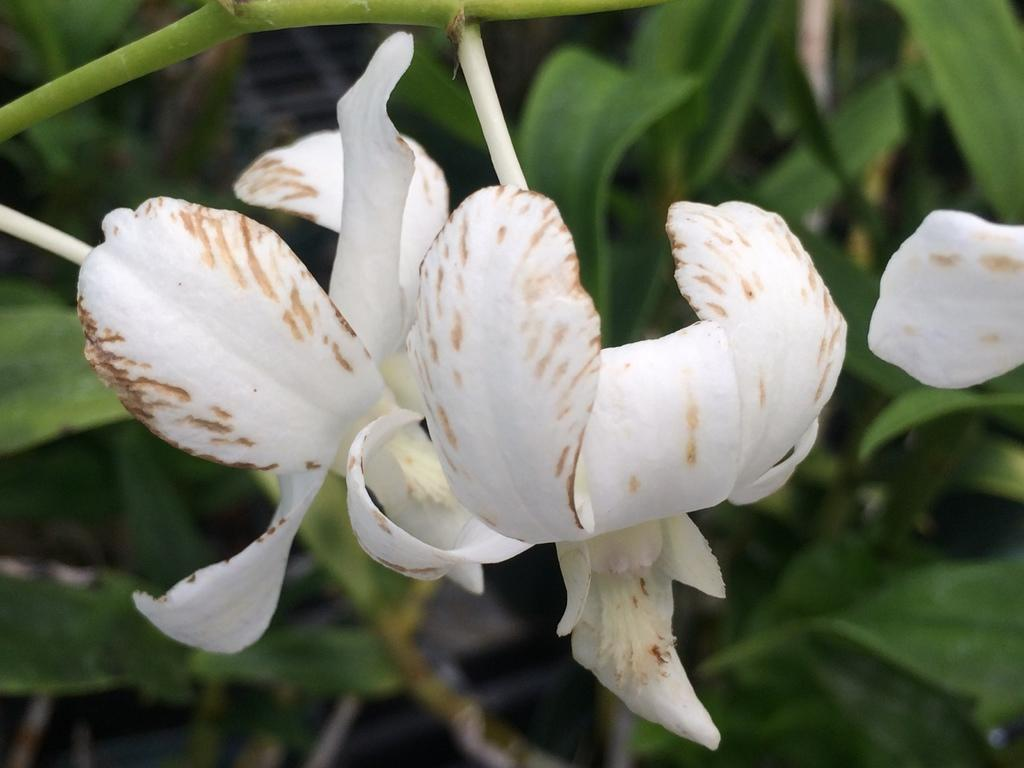What type of flora can be seen in the image? There are flowers in the image. What color are the flowers? The flowers are white in color. What else can be seen in the image besides the flowers? There are stems visible in the image. What type of vegetation can be seen in the background of the image? Green leaves are present in the background of the image. What type of pan is being used to cook the flowers in the image? There is no pan or cooking activity present in the image; it features white flowers with stems and green leaves in the background. 